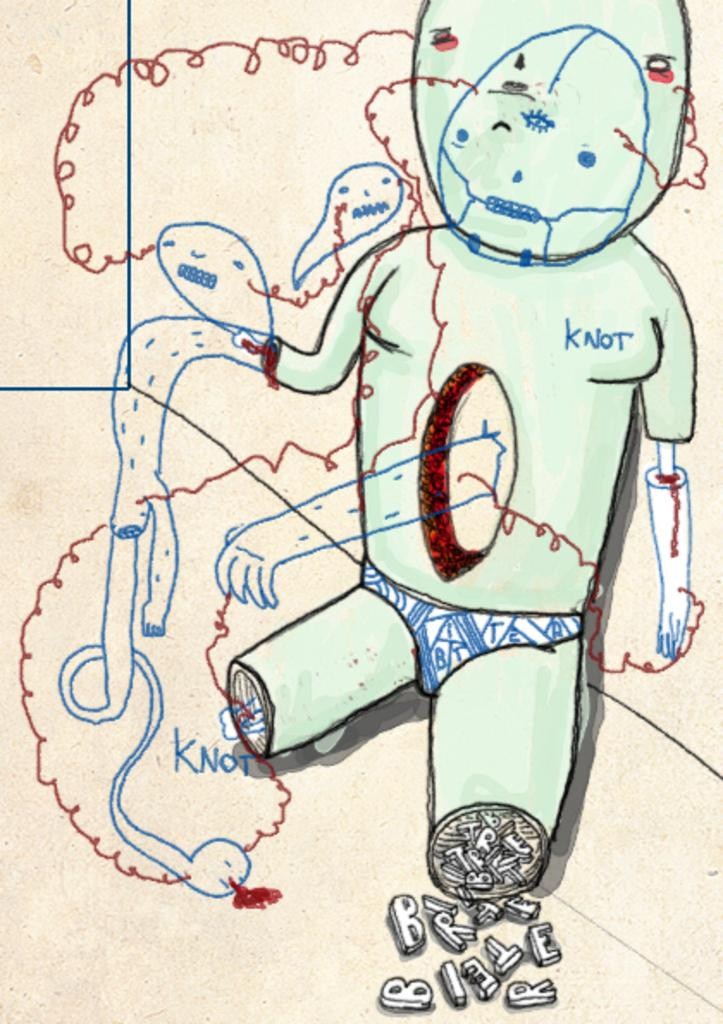What is depicted in the image? There is an art of a person in the image. What color is the background of the image? The background of the image is white. What else can be seen in the image besides the art of the person? There is something written on a paper in the image. How many boys or brothers are present in the image? There are no boys or brothers depicted in the image; it features an art of a person and something written on a paper. 